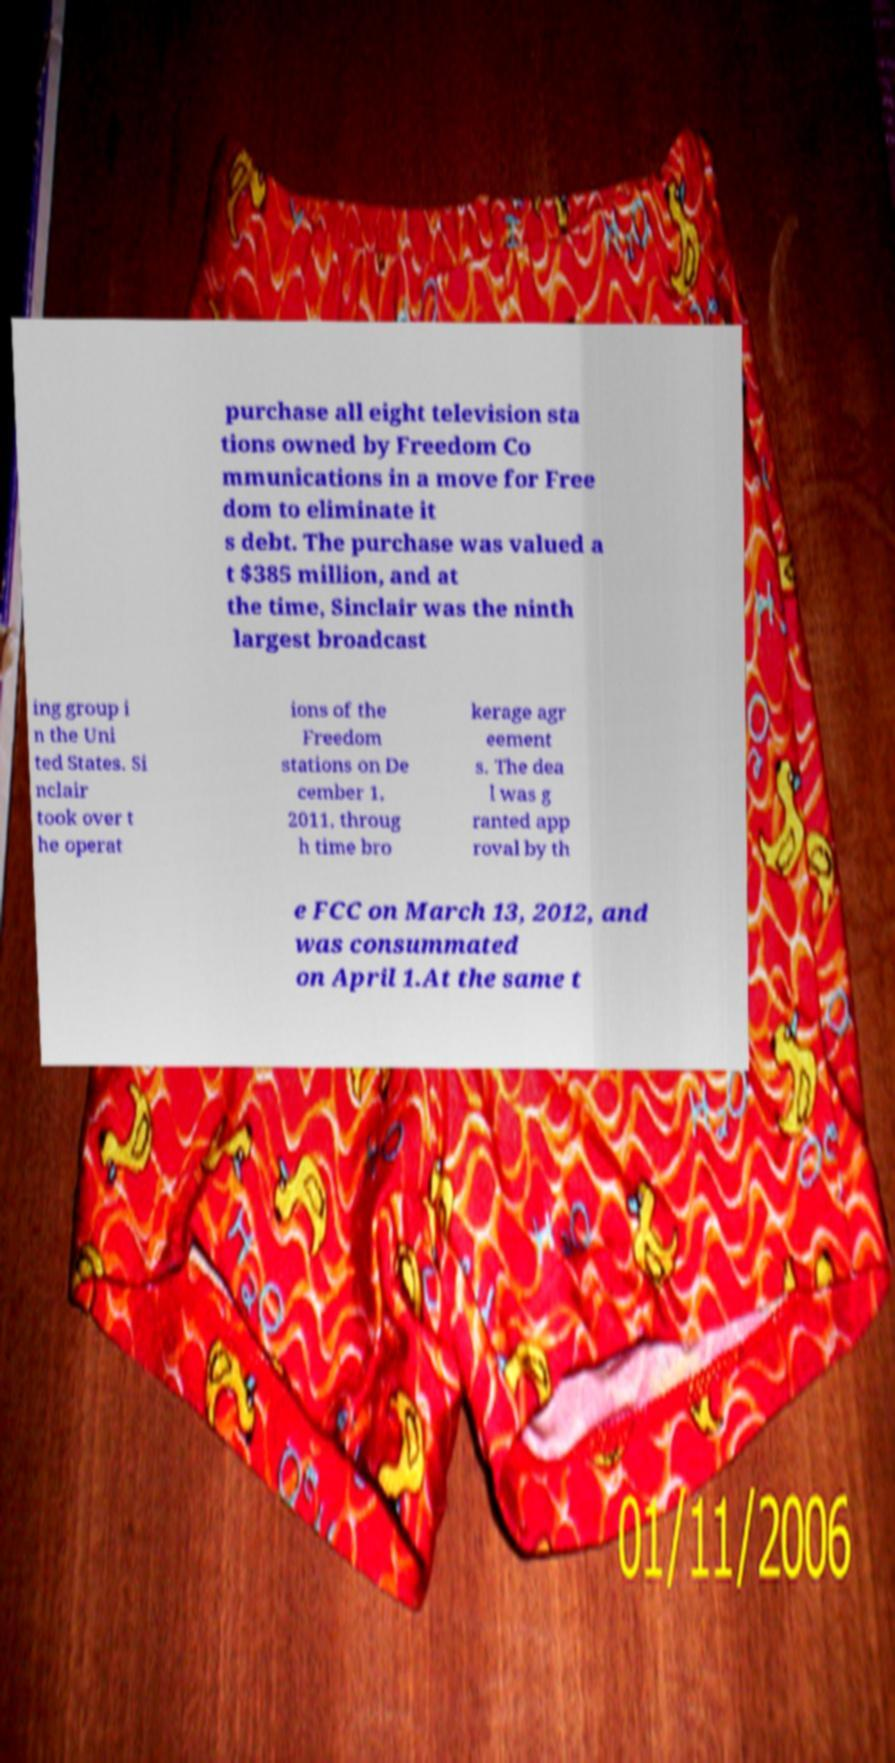Can you accurately transcribe the text from the provided image for me? purchase all eight television sta tions owned by Freedom Co mmunications in a move for Free dom to eliminate it s debt. The purchase was valued a t $385 million, and at the time, Sinclair was the ninth largest broadcast ing group i n the Uni ted States. Si nclair took over t he operat ions of the Freedom stations on De cember 1, 2011, throug h time bro kerage agr eement s. The dea l was g ranted app roval by th e FCC on March 13, 2012, and was consummated on April 1.At the same t 